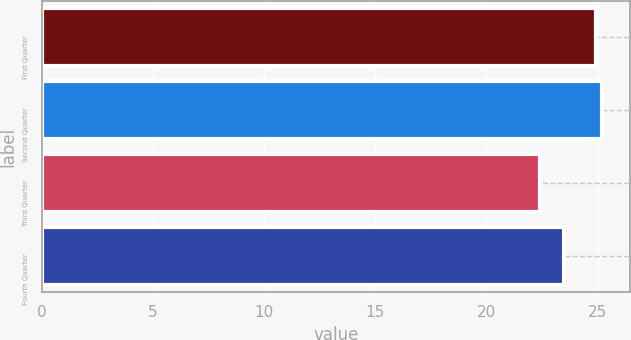Convert chart to OTSL. <chart><loc_0><loc_0><loc_500><loc_500><bar_chart><fcel>First Quarter<fcel>Second Quarter<fcel>Third Quarter<fcel>Fourth Quarter<nl><fcel>24.94<fcel>25.2<fcel>22.41<fcel>23.5<nl></chart> 